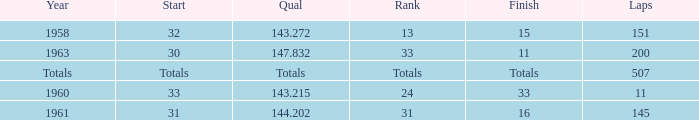What's the Finish rank of 31? 16.0. 